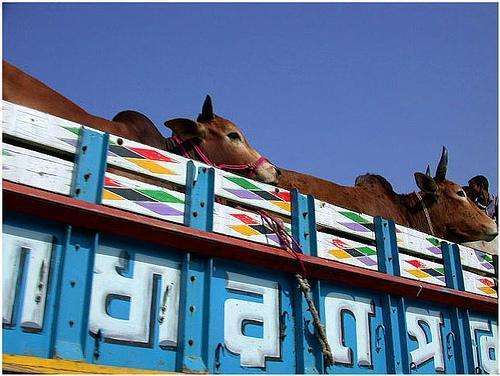How many cows are in the photo?
Give a very brief answer. 2. How many horses are running toward us?
Give a very brief answer. 0. 